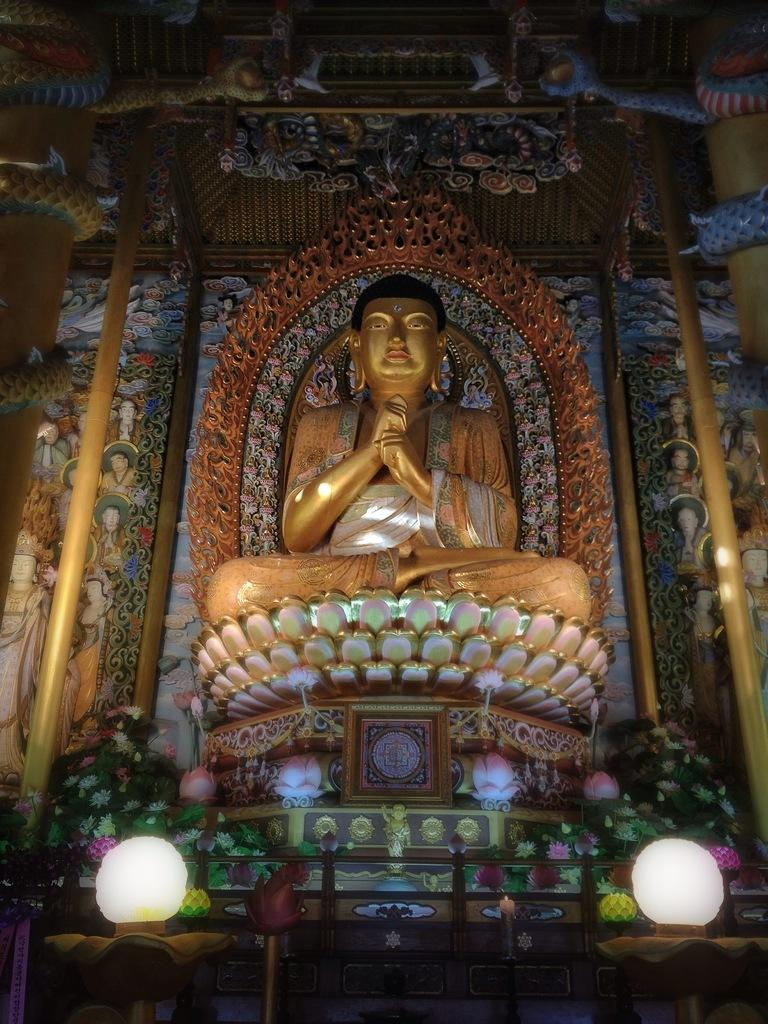What is the main subject of the image? There is a statue of Buddha in the image. What can be seen at the base of the statue? There are two lights at the bottom of the statue. What type of plants are present in the image? There are flowers and leaves in the image. What type of popcorn is being served at the dock in the image? There is no popcorn or dock present in the image; it features a statue of Buddha with lights and flowers. How many cherries are on the tree in the image? There is no tree or cherries present in the image. 